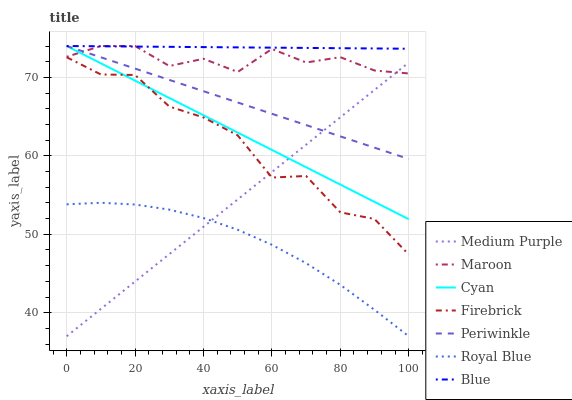Does Royal Blue have the minimum area under the curve?
Answer yes or no. Yes. Does Blue have the maximum area under the curve?
Answer yes or no. Yes. Does Firebrick have the minimum area under the curve?
Answer yes or no. No. Does Firebrick have the maximum area under the curve?
Answer yes or no. No. Is Periwinkle the smoothest?
Answer yes or no. Yes. Is Firebrick the roughest?
Answer yes or no. Yes. Is Maroon the smoothest?
Answer yes or no. No. Is Maroon the roughest?
Answer yes or no. No. Does Medium Purple have the lowest value?
Answer yes or no. Yes. Does Firebrick have the lowest value?
Answer yes or no. No. Does Cyan have the highest value?
Answer yes or no. Yes. Does Firebrick have the highest value?
Answer yes or no. No. Is Firebrick less than Periwinkle?
Answer yes or no. Yes. Is Periwinkle greater than Royal Blue?
Answer yes or no. Yes. Does Cyan intersect Periwinkle?
Answer yes or no. Yes. Is Cyan less than Periwinkle?
Answer yes or no. No. Is Cyan greater than Periwinkle?
Answer yes or no. No. Does Firebrick intersect Periwinkle?
Answer yes or no. No. 